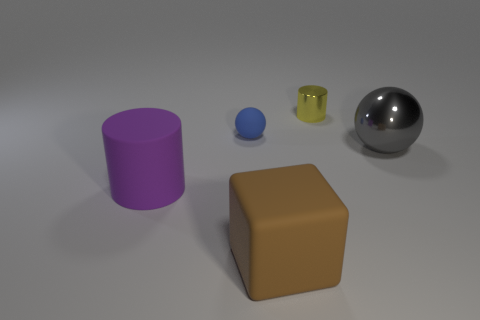There is a shiny object that is on the left side of the large shiny object; is its shape the same as the big rubber thing that is left of the small rubber sphere?
Offer a terse response. Yes. What number of things are yellow spheres or cylinders that are behind the large gray sphere?
Your response must be concise. 1. How many other objects are the same size as the blue matte thing?
Keep it short and to the point. 1. What number of cyan things are small metallic objects or cylinders?
Make the answer very short. 0. There is a tiny object in front of the cylinder that is behind the blue object; what is its shape?
Make the answer very short. Sphere. The blue thing that is the same size as the yellow metal cylinder is what shape?
Make the answer very short. Sphere. Are there an equal number of big brown matte things that are left of the blue rubber object and big gray things in front of the brown rubber cube?
Keep it short and to the point. Yes. Is the shape of the small matte object the same as the metallic object that is in front of the yellow metal thing?
Provide a short and direct response. Yes. What number of other things are there of the same material as the gray ball
Ensure brevity in your answer.  1. There is a gray metal ball; are there any tiny blue matte objects in front of it?
Keep it short and to the point. No. 